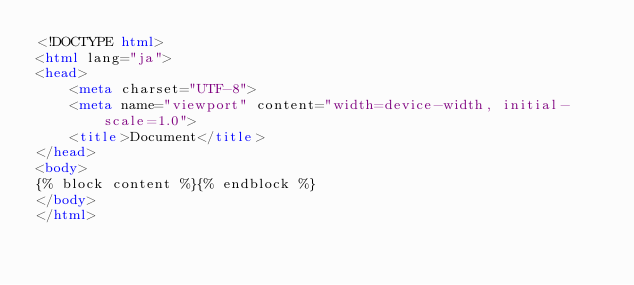Convert code to text. <code><loc_0><loc_0><loc_500><loc_500><_HTML_><!DOCTYPE html>
<html lang="ja">
<head>
    <meta charset="UTF-8">
    <meta name="viewport" content="width=device-width, initial-scale=1.0">
    <title>Document</title>
</head>
<body>
{% block content %}{% endblock %}
</body>
</html></code> 